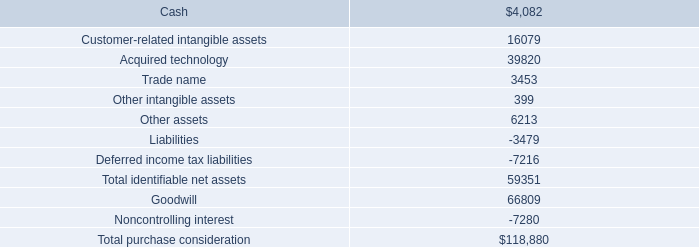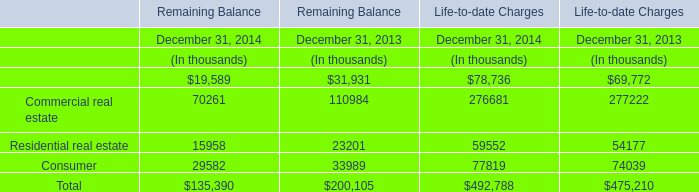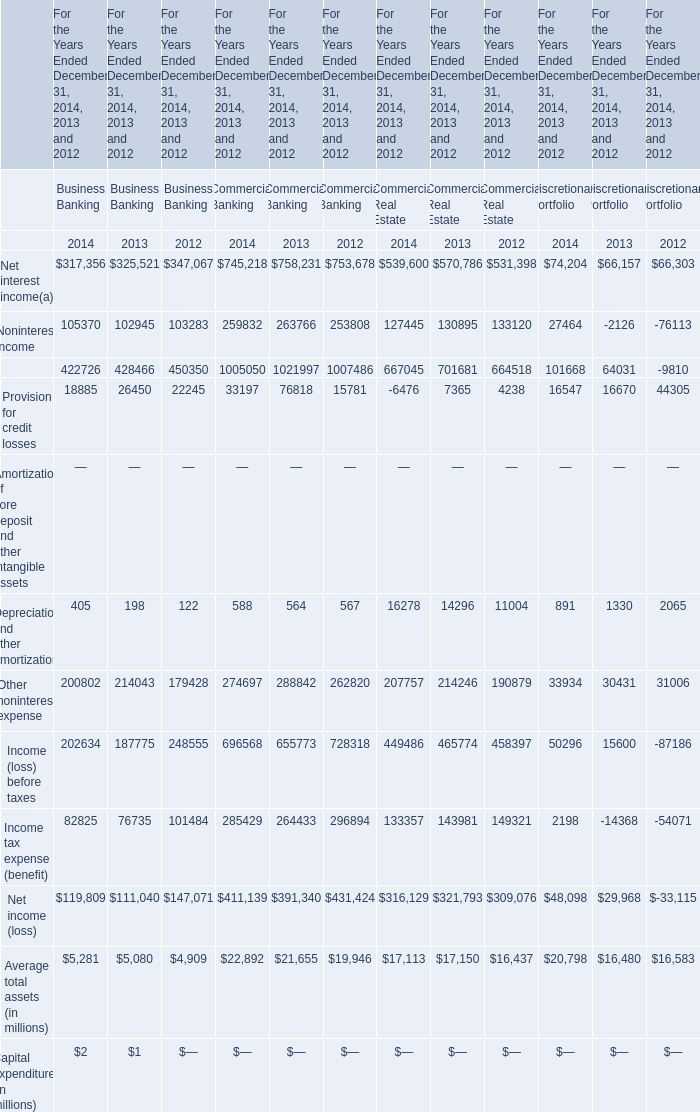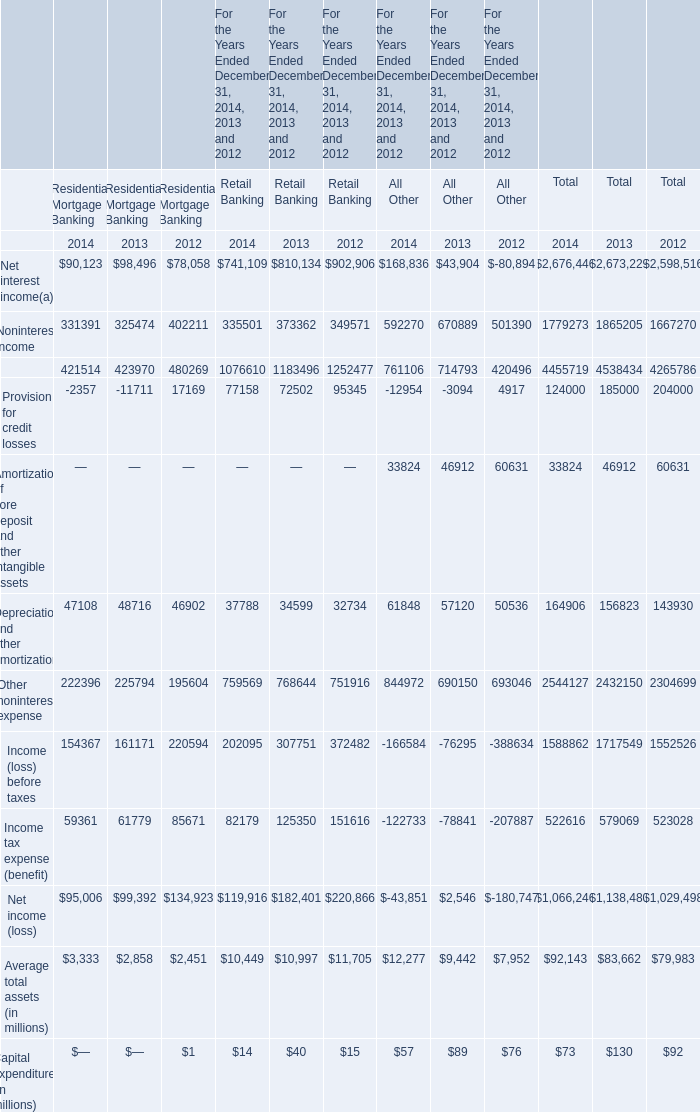What is the percentage of all All Other that are positive to the total amount, in 2014? 
Computations: (((((((168836 + 592270) + 33824) + 61848) + 844972) + 12277) + 57) / ((((((((((168836 + 592270) + 33824) + 61848) + 844972) + 12277) + 57) - 12954) - 166584) - 122733) - 43851))
Answer: 1.25302. 